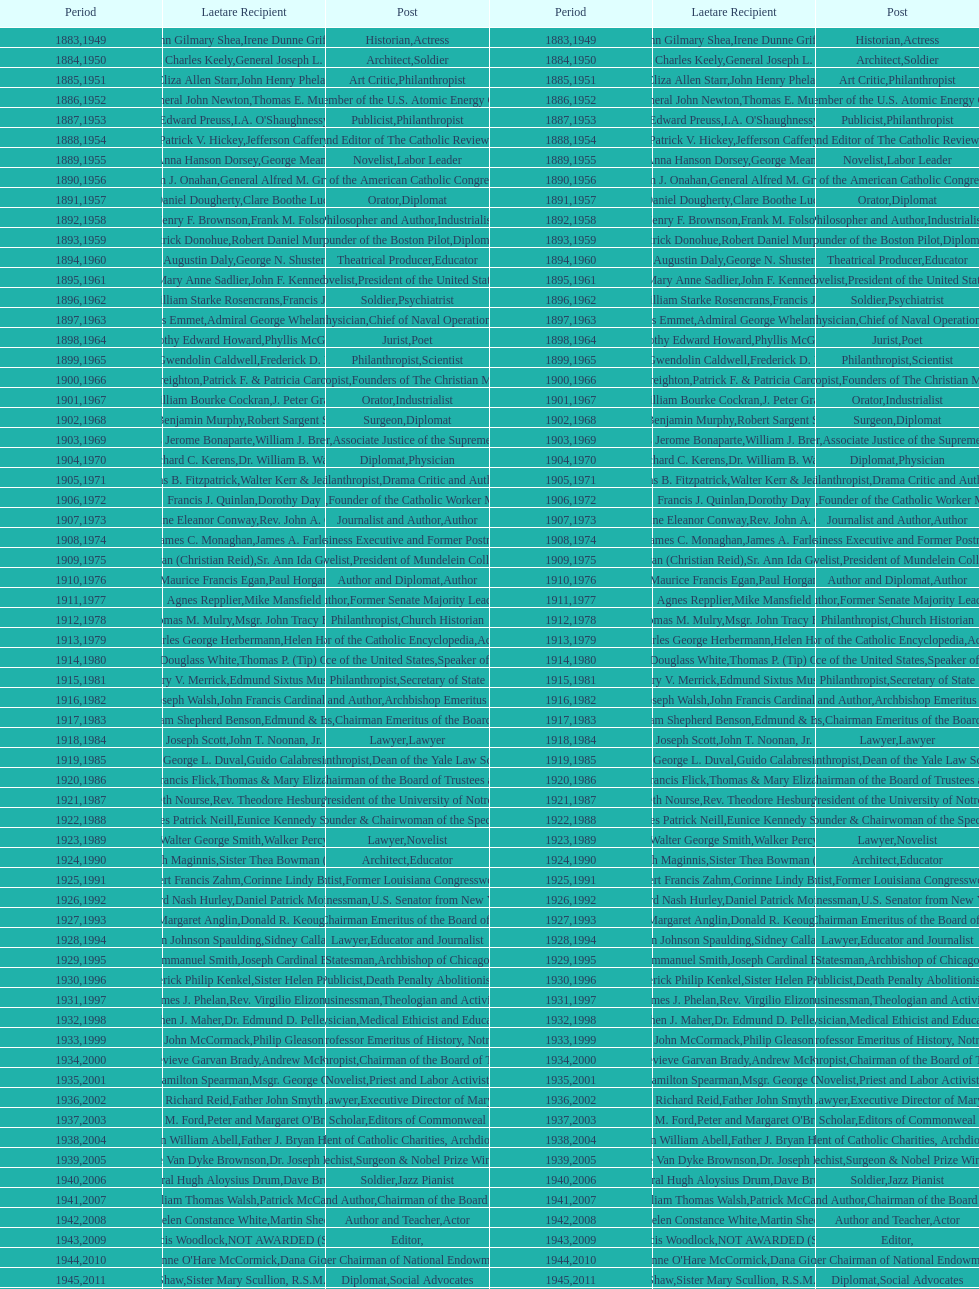How many lawyers have won the award between 1883 and 2014? 5. 